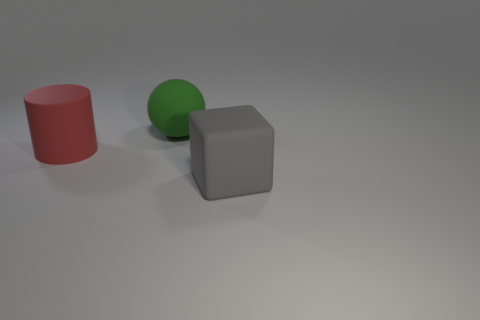Are there any other things that have the same shape as the gray rubber thing?
Offer a terse response. No. What is the big gray object that is in front of the rubber object that is on the left side of the big green matte thing made of?
Give a very brief answer. Rubber. How many objects are cubes or objects that are in front of the big red matte object?
Give a very brief answer. 1. There is a cylinder that is the same material as the big gray cube; what size is it?
Provide a succinct answer. Large. Are there more large rubber cubes right of the big sphere than tiny metal cylinders?
Ensure brevity in your answer.  Yes. What color is the object that is both left of the gray thing and right of the red rubber cylinder?
Offer a terse response. Green. There is a large matte thing in front of the matte cylinder; how many green rubber things are on the left side of it?
Offer a terse response. 1. What is the color of the rubber object that is left of the object that is behind the matte thing left of the big green ball?
Ensure brevity in your answer.  Red. There is a thing that is in front of the red cylinder; does it have the same shape as the red matte thing?
Give a very brief answer. No. What material is the red thing?
Keep it short and to the point. Rubber. 